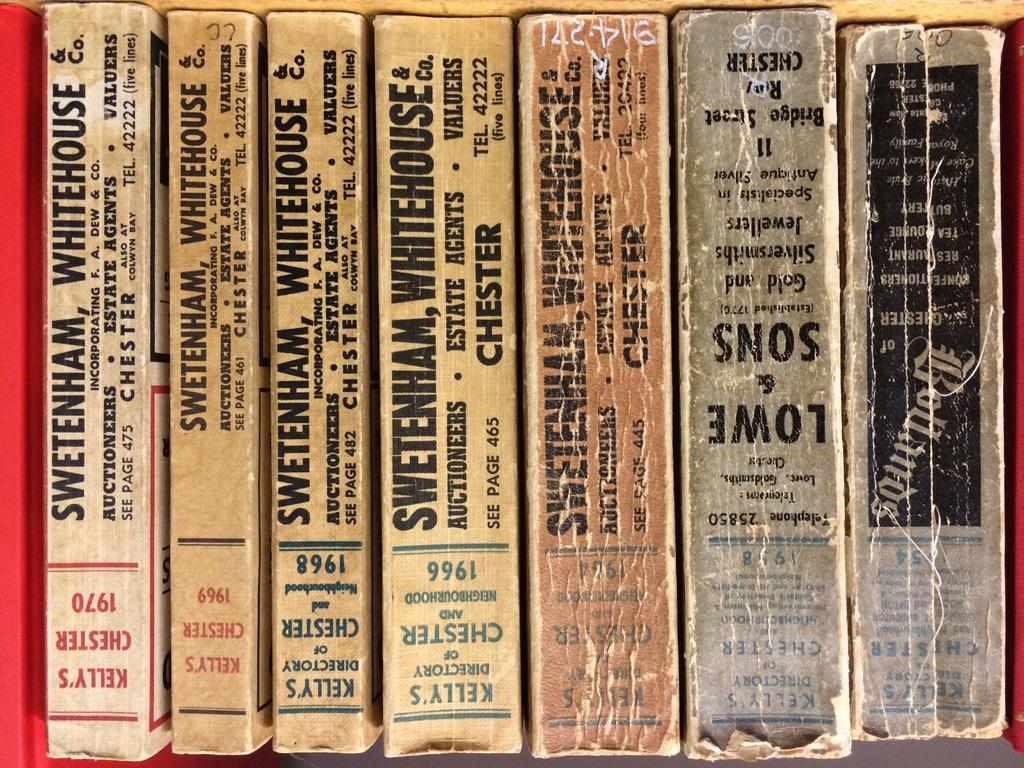<image>
Offer a succinct explanation of the picture presented. Kelly's Chester book collection stacked on a book shelf. 